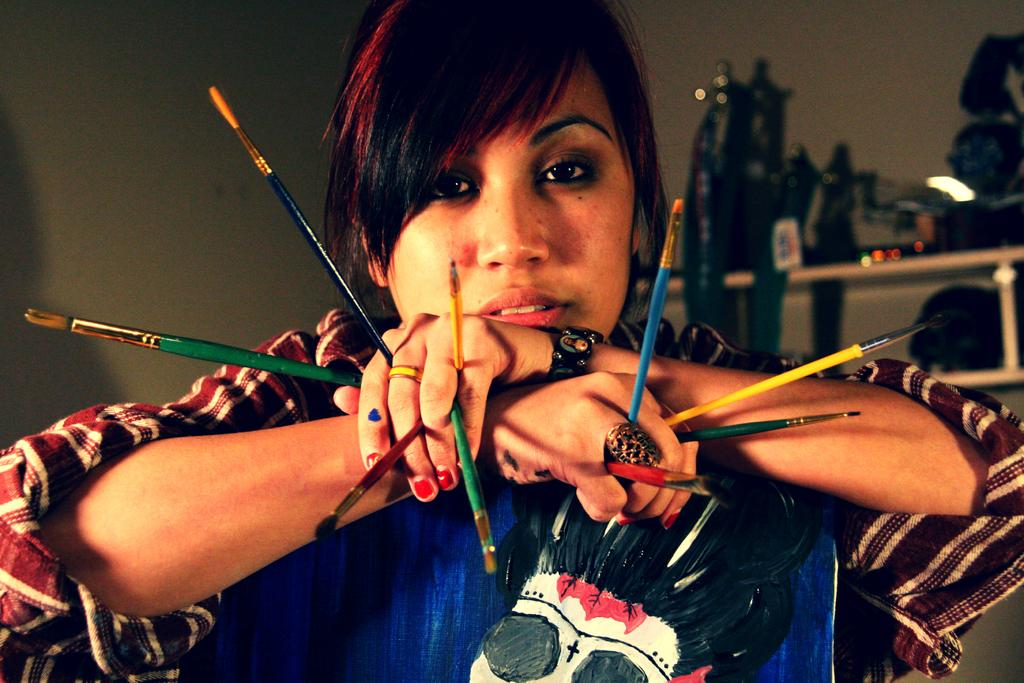What is the lady doing in the image? The lady is standing with her hands on a blue object. What can be seen on the blue object? The blue object has a picture on it. What is the lady holding in her hands? The lady is holding paint brushes. Are there any horses or carriages visible in the image? No, there are no horses or carriages present in the image. Does the lady appear to be expressing any feelings of hate in the image? There is no indication of the lady expressing any feelings of hate in the image. 